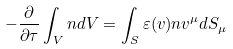Convert formula to latex. <formula><loc_0><loc_0><loc_500><loc_500>- \frac { \partial } { \partial \tau } \int _ { V } n d V = \int _ { S } \varepsilon ( v ) n v ^ { \mu } d S _ { \mu }</formula> 